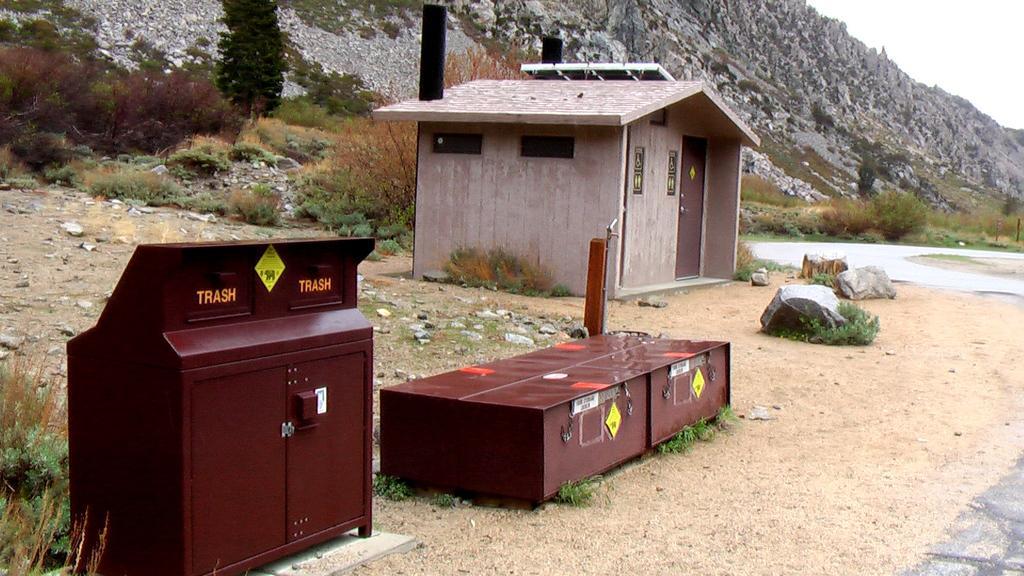Could you give a brief overview of what you see in this image? In the center of the image we can see a hurt, some trees, plants, boxes, rocks are there. In the background of the image hills are there. At the bottom of the image ground is there. At the top right corner of the image sky is there. 